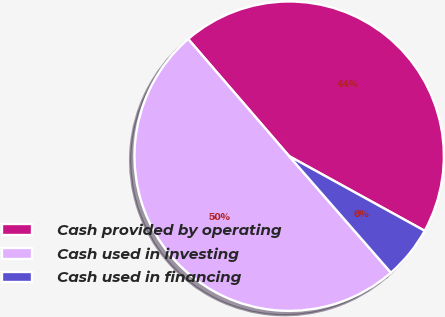<chart> <loc_0><loc_0><loc_500><loc_500><pie_chart><fcel>Cash provided by operating<fcel>Cash used in investing<fcel>Cash used in financing<nl><fcel>44.34%<fcel>50.1%<fcel>5.56%<nl></chart> 